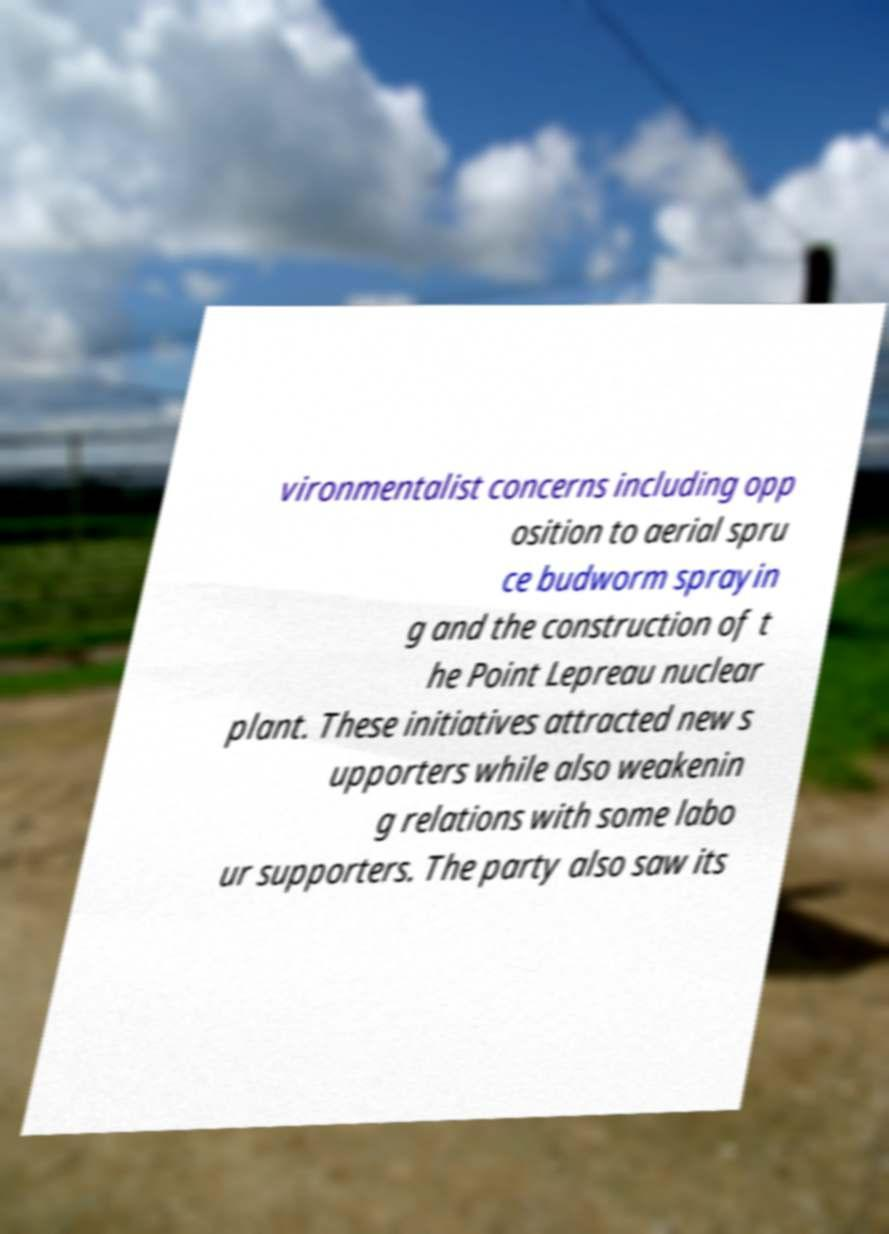What messages or text are displayed in this image? I need them in a readable, typed format. vironmentalist concerns including opp osition to aerial spru ce budworm sprayin g and the construction of t he Point Lepreau nuclear plant. These initiatives attracted new s upporters while also weakenin g relations with some labo ur supporters. The party also saw its 